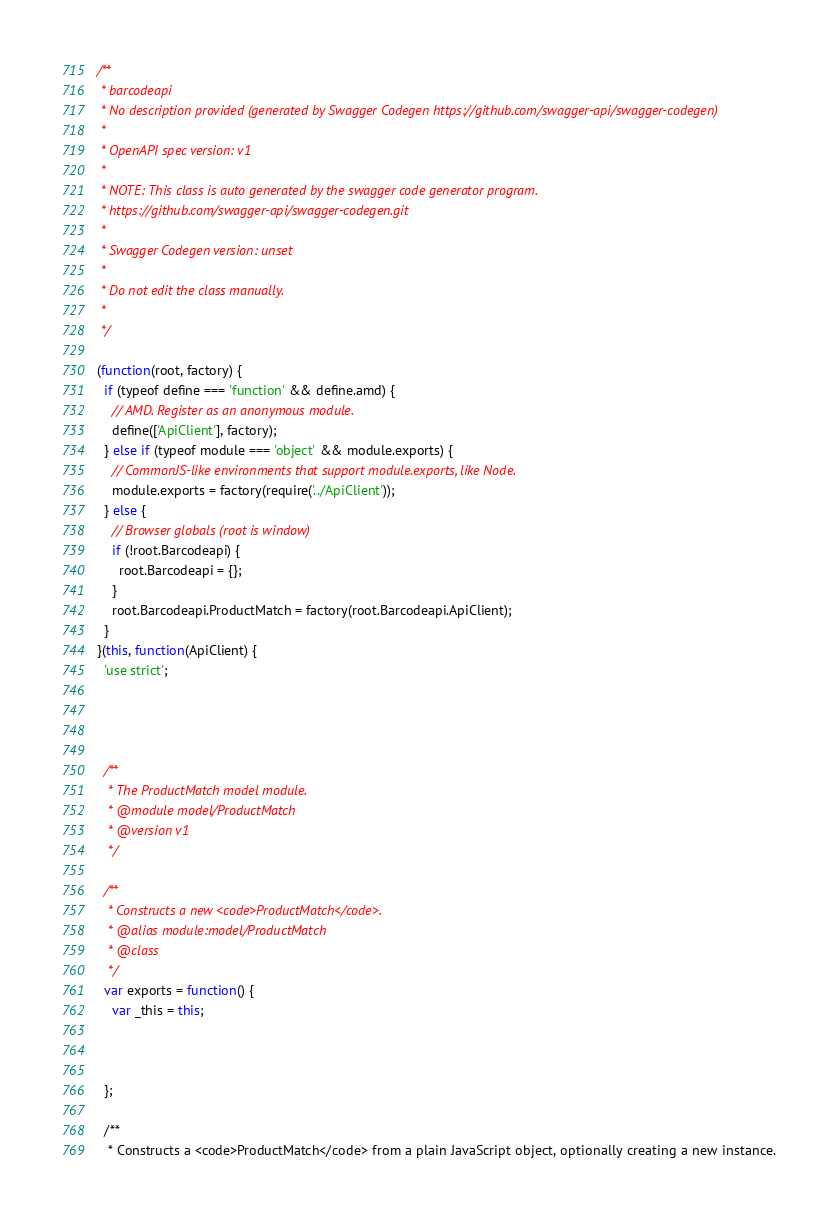Convert code to text. <code><loc_0><loc_0><loc_500><loc_500><_JavaScript_>/**
 * barcodeapi
 * No description provided (generated by Swagger Codegen https://github.com/swagger-api/swagger-codegen)
 *
 * OpenAPI spec version: v1
 *
 * NOTE: This class is auto generated by the swagger code generator program.
 * https://github.com/swagger-api/swagger-codegen.git
 *
 * Swagger Codegen version: unset
 *
 * Do not edit the class manually.
 *
 */

(function(root, factory) {
  if (typeof define === 'function' && define.amd) {
    // AMD. Register as an anonymous module.
    define(['ApiClient'], factory);
  } else if (typeof module === 'object' && module.exports) {
    // CommonJS-like environments that support module.exports, like Node.
    module.exports = factory(require('../ApiClient'));
  } else {
    // Browser globals (root is window)
    if (!root.Barcodeapi) {
      root.Barcodeapi = {};
    }
    root.Barcodeapi.ProductMatch = factory(root.Barcodeapi.ApiClient);
  }
}(this, function(ApiClient) {
  'use strict';




  /**
   * The ProductMatch model module.
   * @module model/ProductMatch
   * @version v1
   */

  /**
   * Constructs a new <code>ProductMatch</code>.
   * @alias module:model/ProductMatch
   * @class
   */
  var exports = function() {
    var _this = this;



  };

  /**
   * Constructs a <code>ProductMatch</code> from a plain JavaScript object, optionally creating a new instance.</code> 